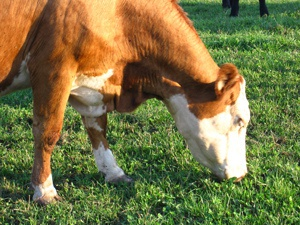Describe the objects in this image and their specific colors. I can see a cow in orange, maroon, brown, and black tones in this image. 